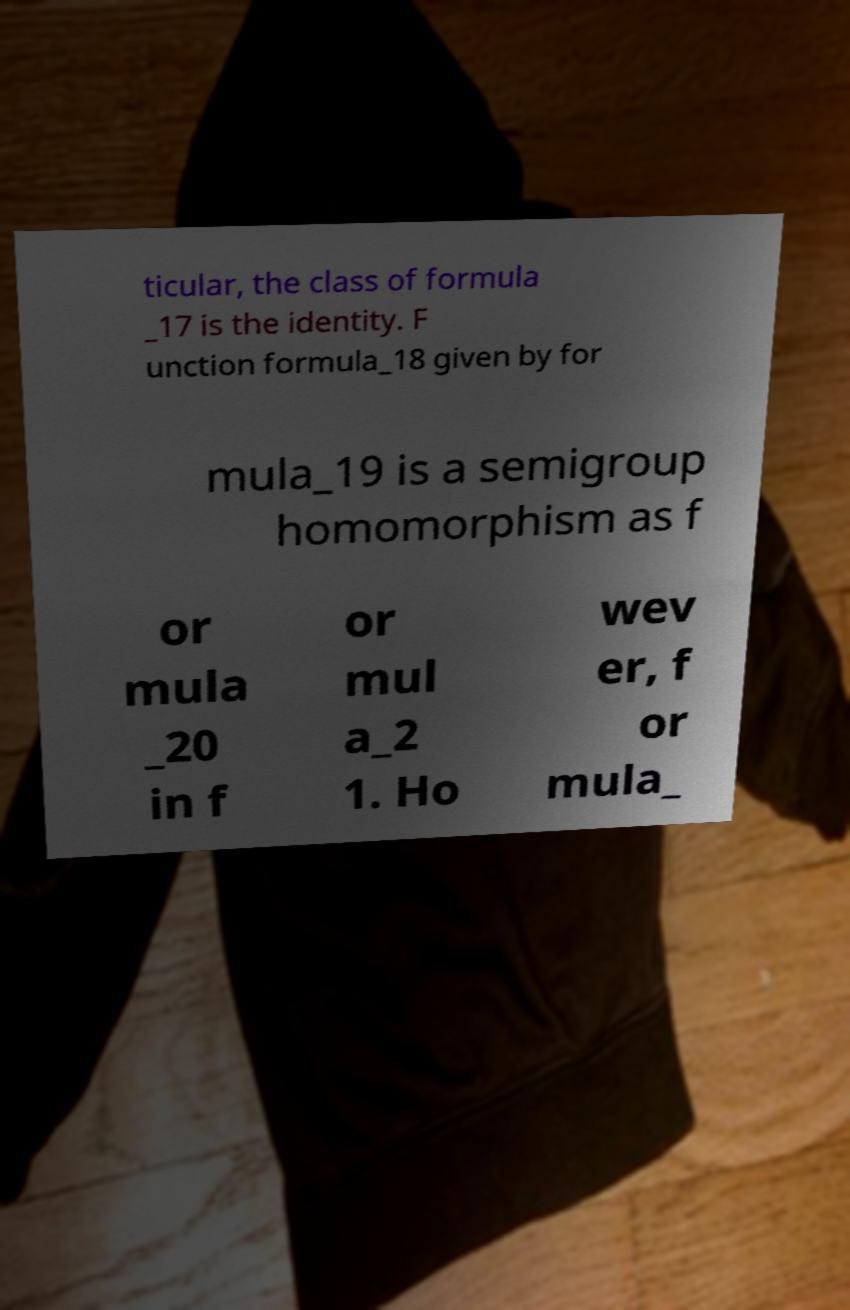Please identify and transcribe the text found in this image. ticular, the class of formula _17 is the identity. F unction formula_18 given by for mula_19 is a semigroup homomorphism as f or mula _20 in f or mul a_2 1. Ho wev er, f or mula_ 